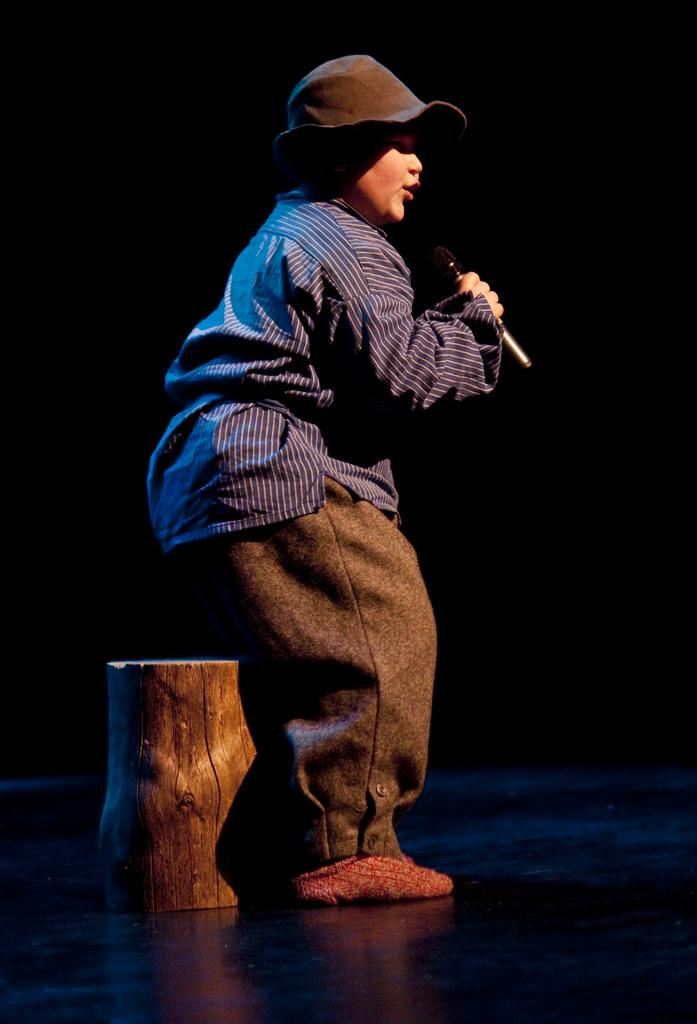Who is the main subject in the image? There is a boy in the image. What is the boy holding in the image? The boy is holding a microphone. What is the boy doing with the microphone? The boy is singing a song. What is the boy wearing on his head? The boy is wearing a hat. What piece of furniture is present in the image? There is a wooden stool in the image. Can you see any cobwebs in the image? There is no mention of cobwebs in the image, so we cannot determine if they are present or not. 